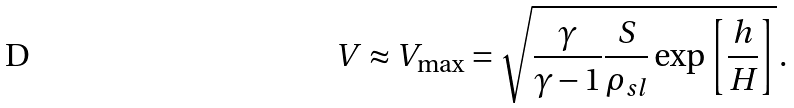<formula> <loc_0><loc_0><loc_500><loc_500>V \approx V _ { \max } = \sqrt { \frac { \gamma } { \gamma - 1 } \frac { S } { \rho _ { s l } } \exp \left [ \frac { h } { H } \right ] } \, .</formula> 